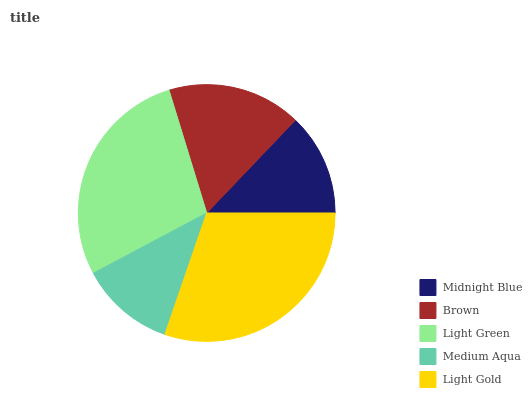Is Medium Aqua the minimum?
Answer yes or no. Yes. Is Light Gold the maximum?
Answer yes or no. Yes. Is Brown the minimum?
Answer yes or no. No. Is Brown the maximum?
Answer yes or no. No. Is Brown greater than Midnight Blue?
Answer yes or no. Yes. Is Midnight Blue less than Brown?
Answer yes or no. Yes. Is Midnight Blue greater than Brown?
Answer yes or no. No. Is Brown less than Midnight Blue?
Answer yes or no. No. Is Brown the high median?
Answer yes or no. Yes. Is Brown the low median?
Answer yes or no. Yes. Is Midnight Blue the high median?
Answer yes or no. No. Is Light Gold the low median?
Answer yes or no. No. 